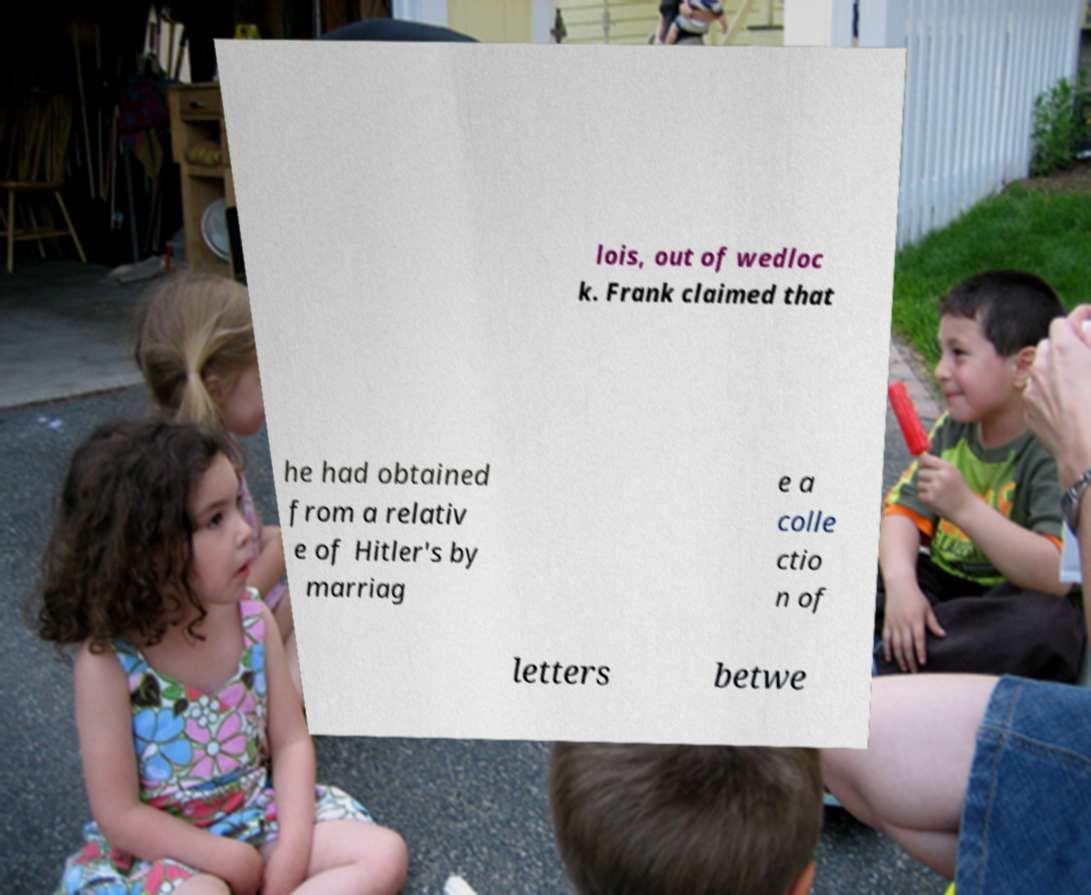Could you extract and type out the text from this image? lois, out of wedloc k. Frank claimed that he had obtained from a relativ e of Hitler's by marriag e a colle ctio n of letters betwe 